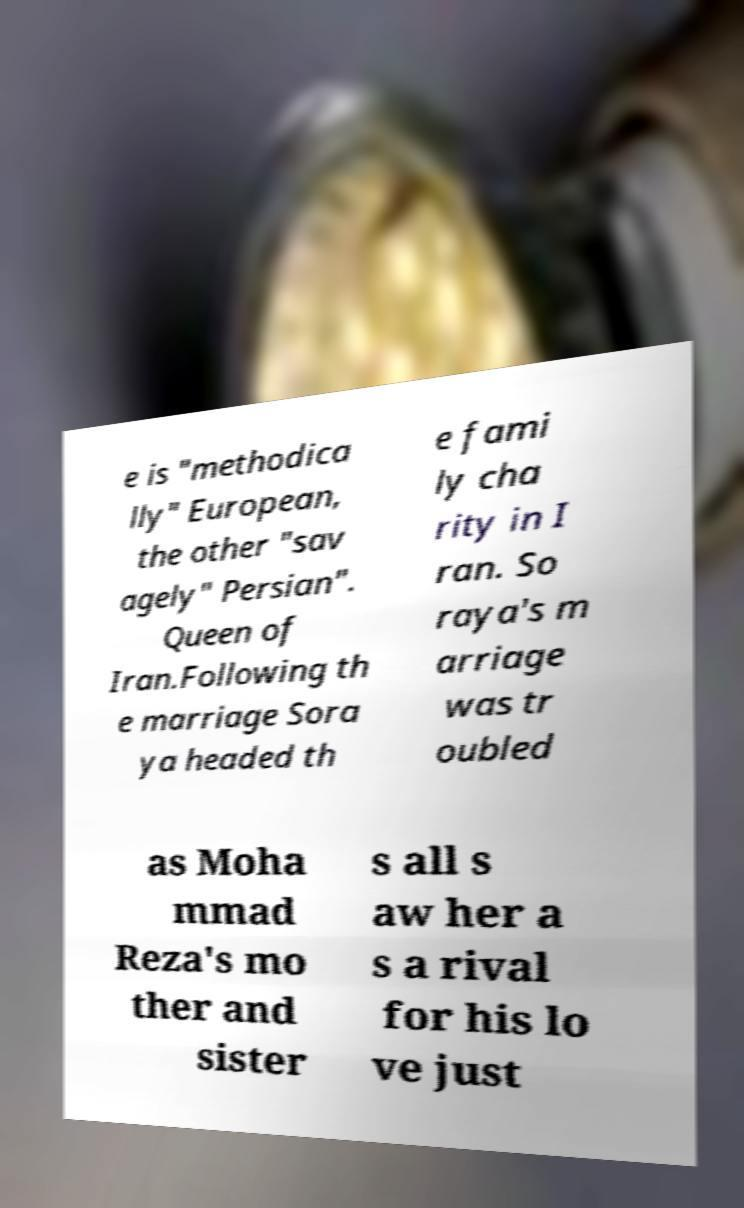For documentation purposes, I need the text within this image transcribed. Could you provide that? e is "methodica lly" European, the other "sav agely" Persian". Queen of Iran.Following th e marriage Sora ya headed th e fami ly cha rity in I ran. So raya's m arriage was tr oubled as Moha mmad Reza's mo ther and sister s all s aw her a s a rival for his lo ve just 